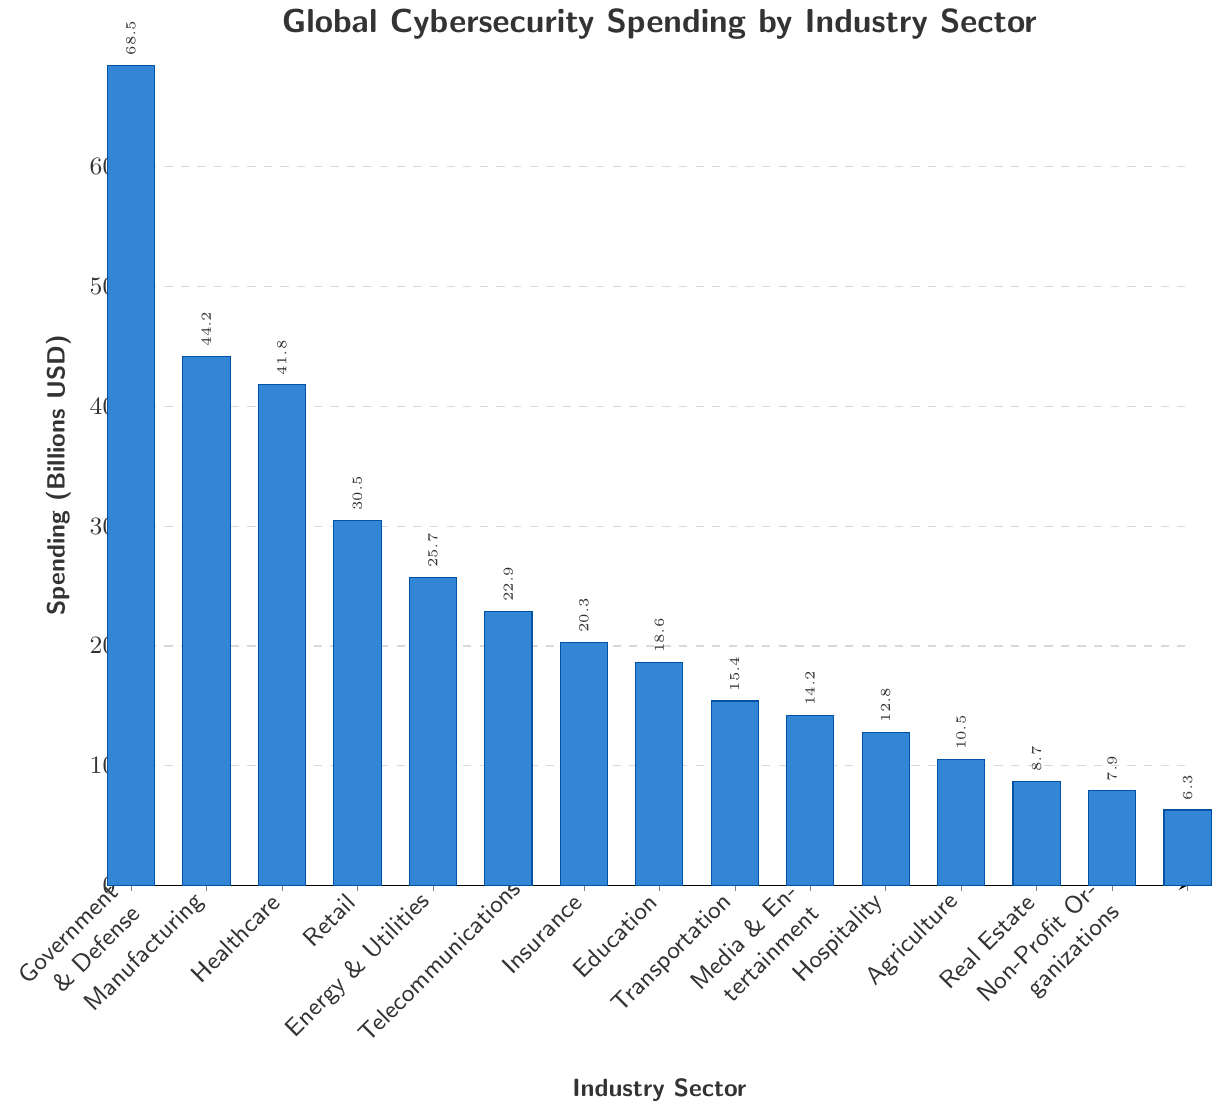What's the industry with the highest spending on cybersecurity? The industry with the highest bar represents the highest spending. In the figure, the bar for "Banking & Financial Services" is the tallest, indicating it has the highest spending.
Answer: Banking & Financial Services What is the total cybersecurity spending of the top three industries combined? To find the total spending of the top three industries, sum the spending of Banking & Financial Services (68.5), Government & Defense (44.2), and Manufacturing (41.8). The total is 68.5 + 44.2 + 41.8 = 154.5 billion USD.
Answer: 154.5 billion USD Which industry spends more on cybersecurity: Healthcare or Energy & Utilities? Compare the heights of the bars for "Healthcare" and "Energy & Utilities". Healthcare has a spending of 30.5 billion USD, while Energy & Utilities has 22.9 billion USD.
Answer: Healthcare What is the difference in cybersecurity spending between Education and Telecommunications sectors? Subtract the spending of Telecommunications from Education. Education spends 15.4 billion USD and Telecommunications spends 20.3 billion USD. The difference is 20.3 - 15.4 = 4.9 billion USD.
Answer: 4.9 billion USD How much more does the Retail sector spend compared to the Non-Profit Organizations sector? Subtract the spending of Non-Profit Organizations from the spending of the Retail sector. Retail spends 25.7 billion USD and Non-Profit Organizations spend 6.3 billion USD. The difference is 25.7 - 6.3 = 19.4 billion USD.
Answer: 19.4 billion USD Among the sectors with spending less than 15 billion USD, which has the highest cybersecurity spending? Identify the sectors with spending less than 15 billion USD: Transportation, Media & Entertainment, Hospitality, Agriculture, Real Estate, Non-Profit Organizations. Among these, Transportation has the highest spending at 14.2 billion USD.
Answer: Transportation What is the average cybersecurity spending of the Manufacturing, Healthcare, and Retail sectors? Sum the spending of Manufacturing, Healthcare, and Retail, then divide by 3. Manufacturing spends 41.8 billion USD, Healthcare spends 30.5 billion USD, and Retail spends 25.7 billion USD. The average is (41.8 + 30.5 + 25.7) / 3 = 32.67 billion USD.
Answer: 32.67 billion USD Is the cybersecurity spending of the Telecommunications sector greater than the combination of Agriculture and Real Estate sectors? Combine the spending of Agriculture and Real Estate, then compare to Telecommunications. Agriculture spends 8.7 billion USD and Real Estate spends 7.9 billion USD, combined they spend 8.7 + 7.9 = 16.6 billion USD. Telecommunications spends 20.3 billion USD which is greater than 16.6 billion USD.
Answer: Yes Which sector has lower spending on cybersecurity, Hospitality or Media & Entertainment? Compare the heights of the bars for "Hospitality" and "Media & Entertainment". Hospitality spends 10.5 billion USD and Media & Entertainment spends 12.8 billion USD. Hospitality has lower spending.
Answer: Hospitality 